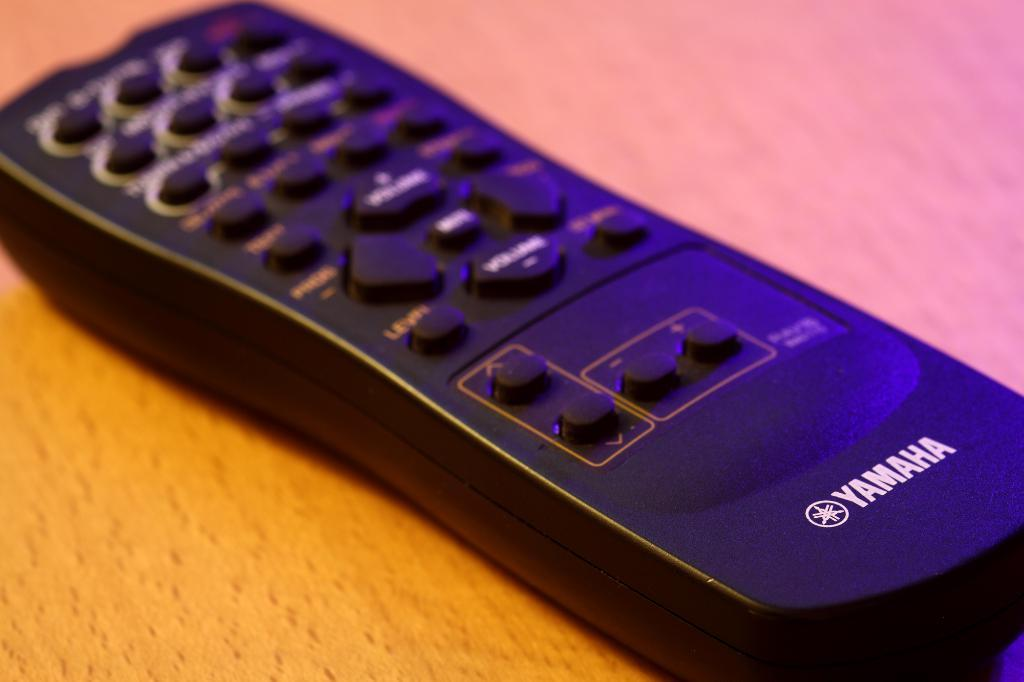<image>
Summarize the visual content of the image. A Yamaha remote control sits on a table. 